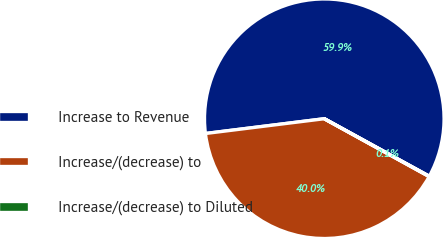Convert chart. <chart><loc_0><loc_0><loc_500><loc_500><pie_chart><fcel>Increase to Revenue<fcel>Increase/(decrease) to<fcel>Increase/(decrease) to Diluted<nl><fcel>59.94%<fcel>40.01%<fcel>0.05%<nl></chart> 